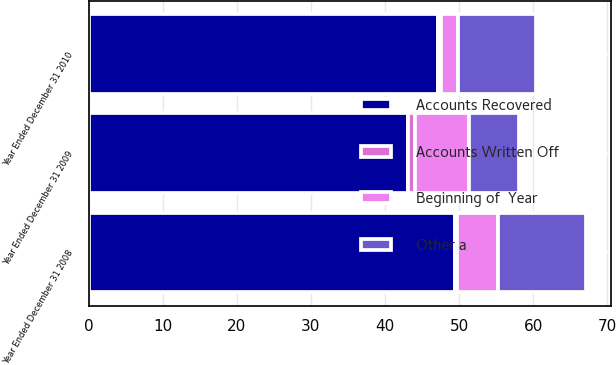<chart> <loc_0><loc_0><loc_500><loc_500><stacked_bar_chart><ecel><fcel>Year Ended December 31 2010<fcel>Year Ended December 31 2009<fcel>Year Ended December 31 2008<nl><fcel>Accounts Recovered<fcel>47.2<fcel>43.1<fcel>49.5<nl><fcel>Beginning of  Year<fcel>2.2<fcel>7.3<fcel>5.5<nl><fcel>Accounts Written Off<fcel>0.4<fcel>1<fcel>0.2<nl><fcel>Other a<fcel>10.6<fcel>6.7<fcel>11.9<nl></chart> 